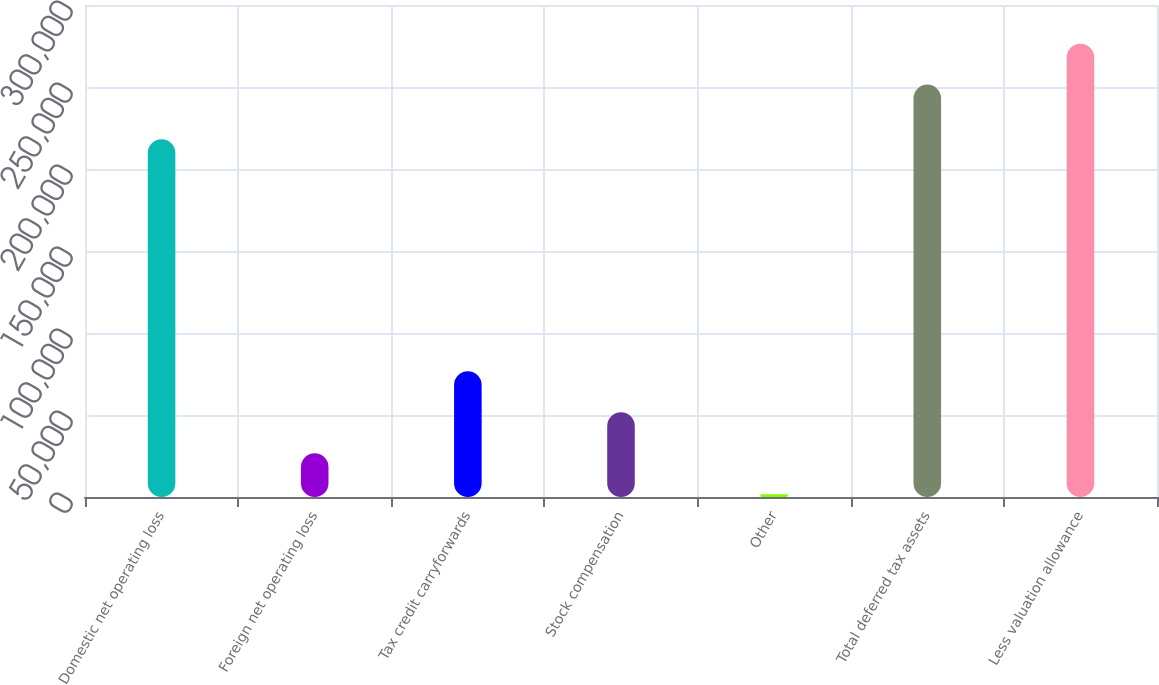Convert chart to OTSL. <chart><loc_0><loc_0><loc_500><loc_500><bar_chart><fcel>Domestic net operating loss<fcel>Foreign net operating loss<fcel>Tax credit carryforwards<fcel>Stock compensation<fcel>Other<fcel>Total deferred tax assets<fcel>Less valuation allowance<nl><fcel>218169<fcel>26714<fcel>76656<fcel>51685<fcel>1743<fcel>251453<fcel>276424<nl></chart> 